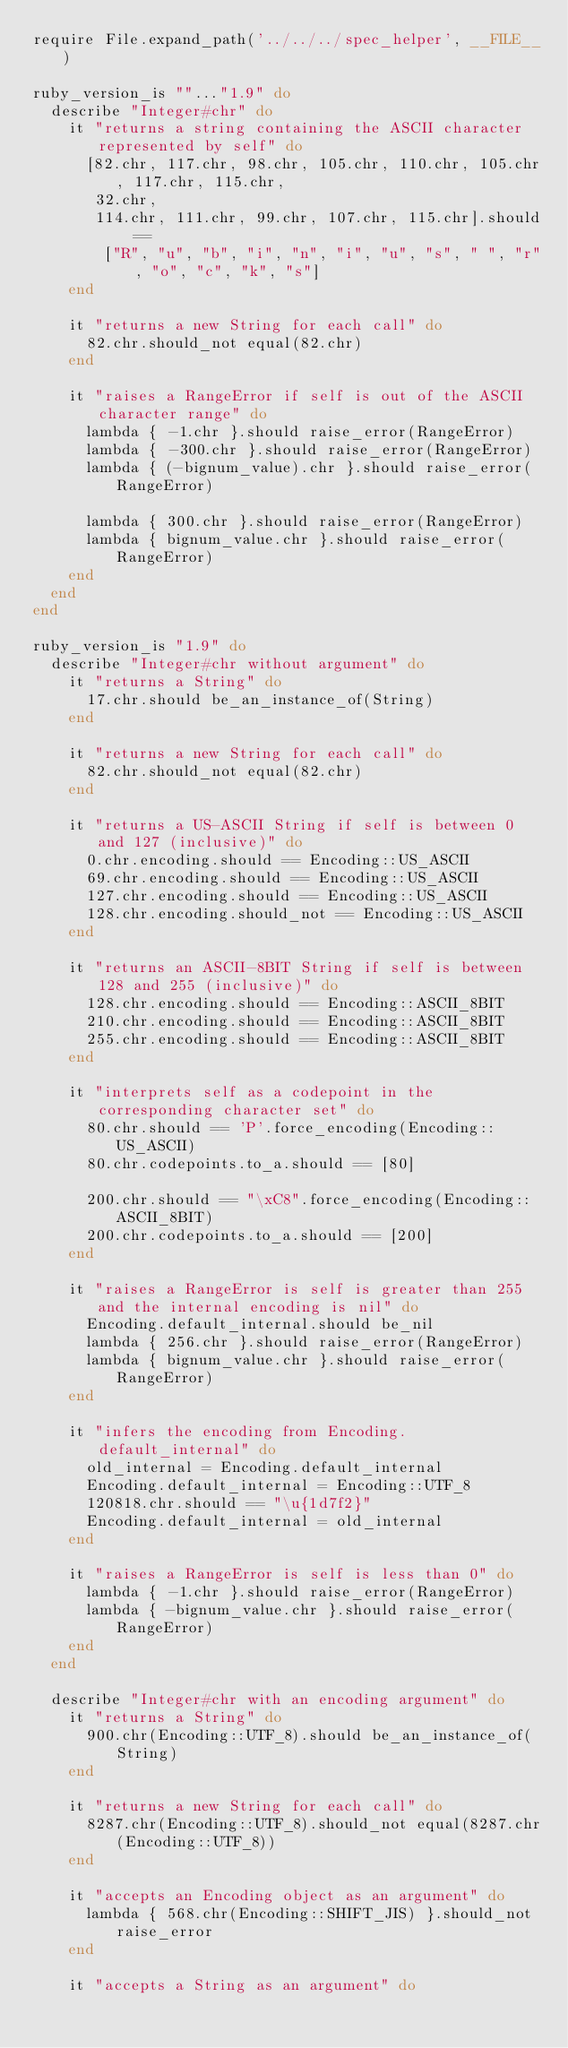Convert code to text. <code><loc_0><loc_0><loc_500><loc_500><_Ruby_>require File.expand_path('../../../spec_helper', __FILE__)

ruby_version_is ""..."1.9" do
  describe "Integer#chr" do
    it "returns a string containing the ASCII character represented by self" do
      [82.chr, 117.chr, 98.chr, 105.chr, 110.chr, 105.chr, 117.chr, 115.chr, 
       32.chr, 
       114.chr, 111.chr, 99.chr, 107.chr, 115.chr].should == 
        ["R", "u", "b", "i", "n", "i", "u", "s", " ", "r", "o", "c", "k", "s"]
    end

    it "returns a new String for each call" do
      82.chr.should_not equal(82.chr)
    end
    
    it "raises a RangeError if self is out of the ASCII character range" do
      lambda { -1.chr }.should raise_error(RangeError)
      lambda { -300.chr }.should raise_error(RangeError)
      lambda { (-bignum_value).chr }.should raise_error(RangeError)

      lambda { 300.chr }.should raise_error(RangeError)
      lambda { bignum_value.chr }.should raise_error(RangeError)
    end
  end
end

ruby_version_is "1.9" do
  describe "Integer#chr without argument" do
    it "returns a String" do
      17.chr.should be_an_instance_of(String)
    end

    it "returns a new String for each call" do
      82.chr.should_not equal(82.chr)
    end

    it "returns a US-ASCII String if self is between 0 and 127 (inclusive)" do
      0.chr.encoding.should == Encoding::US_ASCII
      69.chr.encoding.should == Encoding::US_ASCII
      127.chr.encoding.should == Encoding::US_ASCII
      128.chr.encoding.should_not == Encoding::US_ASCII
    end

    it "returns an ASCII-8BIT String if self is between 128 and 255 (inclusive)" do
      128.chr.encoding.should == Encoding::ASCII_8BIT
      210.chr.encoding.should == Encoding::ASCII_8BIT
      255.chr.encoding.should == Encoding::ASCII_8BIT
    end

    it "interprets self as a codepoint in the corresponding character set" do
      80.chr.should == 'P'.force_encoding(Encoding::US_ASCII)
      80.chr.codepoints.to_a.should == [80]

      200.chr.should == "\xC8".force_encoding(Encoding::ASCII_8BIT)
      200.chr.codepoints.to_a.should == [200]
    end

    it "raises a RangeError is self is greater than 255 and the internal encoding is nil" do
      Encoding.default_internal.should be_nil
      lambda { 256.chr }.should raise_error(RangeError)
      lambda { bignum_value.chr }.should raise_error(RangeError)
    end

    it "infers the encoding from Encoding.default_internal" do
      old_internal = Encoding.default_internal
      Encoding.default_internal = Encoding::UTF_8
      120818.chr.should == "\u{1d7f2}"
      Encoding.default_internal = old_internal
    end

    it "raises a RangeError is self is less than 0" do
      lambda { -1.chr }.should raise_error(RangeError)
      lambda { -bignum_value.chr }.should raise_error(RangeError)
    end
  end

  describe "Integer#chr with an encoding argument" do
    it "returns a String" do
      900.chr(Encoding::UTF_8).should be_an_instance_of(String)
    end

    it "returns a new String for each call" do
      8287.chr(Encoding::UTF_8).should_not equal(8287.chr(Encoding::UTF_8))
    end

    it "accepts an Encoding object as an argument" do
      lambda { 568.chr(Encoding::SHIFT_JIS) }.should_not raise_error
    end

    it "accepts a String as an argument" do</code> 